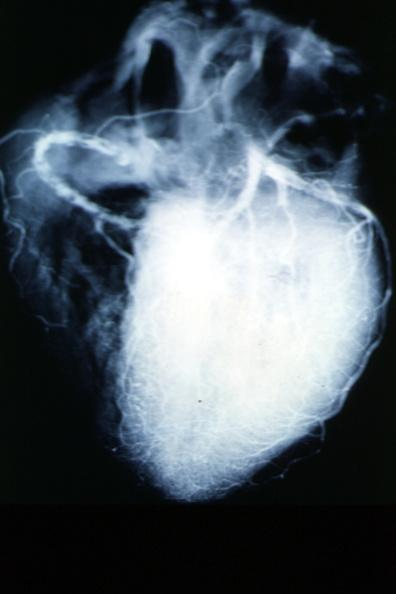does aldehyde fuscin show x-ray postmortcoronary arteries with multiple lesions?
Answer the question using a single word or phrase. No 